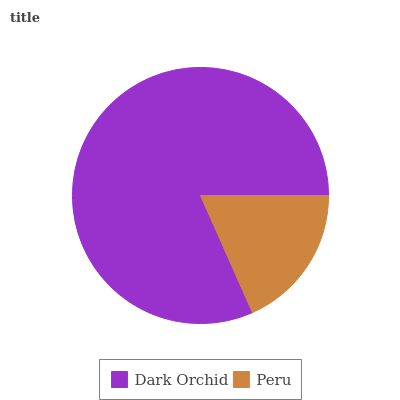Is Peru the minimum?
Answer yes or no. Yes. Is Dark Orchid the maximum?
Answer yes or no. Yes. Is Peru the maximum?
Answer yes or no. No. Is Dark Orchid greater than Peru?
Answer yes or no. Yes. Is Peru less than Dark Orchid?
Answer yes or no. Yes. Is Peru greater than Dark Orchid?
Answer yes or no. No. Is Dark Orchid less than Peru?
Answer yes or no. No. Is Dark Orchid the high median?
Answer yes or no. Yes. Is Peru the low median?
Answer yes or no. Yes. Is Peru the high median?
Answer yes or no. No. Is Dark Orchid the low median?
Answer yes or no. No. 